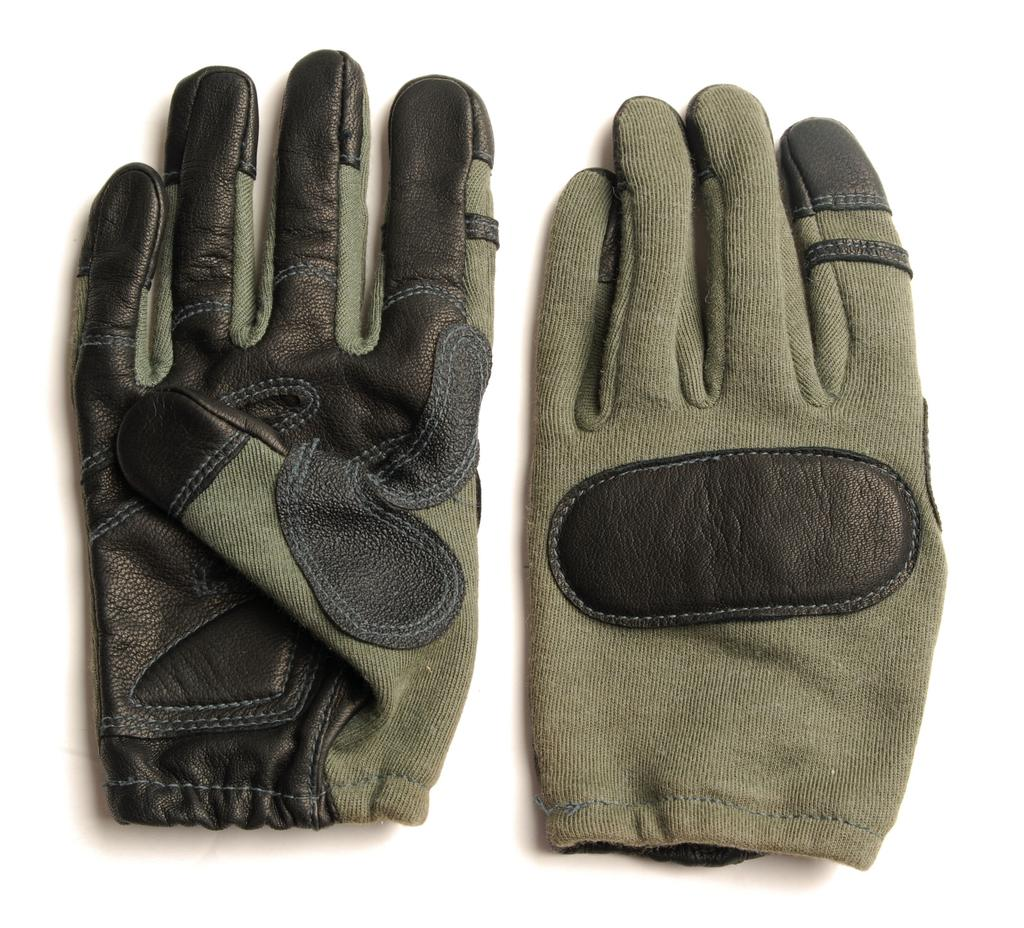What type of clothing item is present in the image? There is a pair of gloves in the image. What is the color of the surface where the gloves are placed? The gloves are on a white surface. Are there any popcorn kernels visible on the white surface in the image? There is no mention of popcorn kernels in the provided facts, so we cannot determine if they are present in the image. 